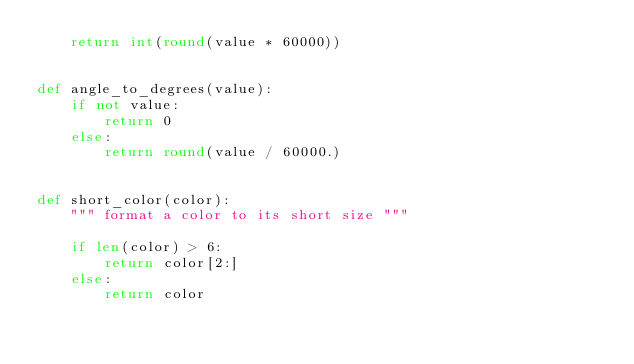<code> <loc_0><loc_0><loc_500><loc_500><_Python_>    return int(round(value * 60000))


def angle_to_degrees(value):
    if not value:
        return 0
    else:
        return round(value / 60000.)


def short_color(color):
    """ format a color to its short size """

    if len(color) > 6:
        return color[2:]
    else:
        return color
</code> 